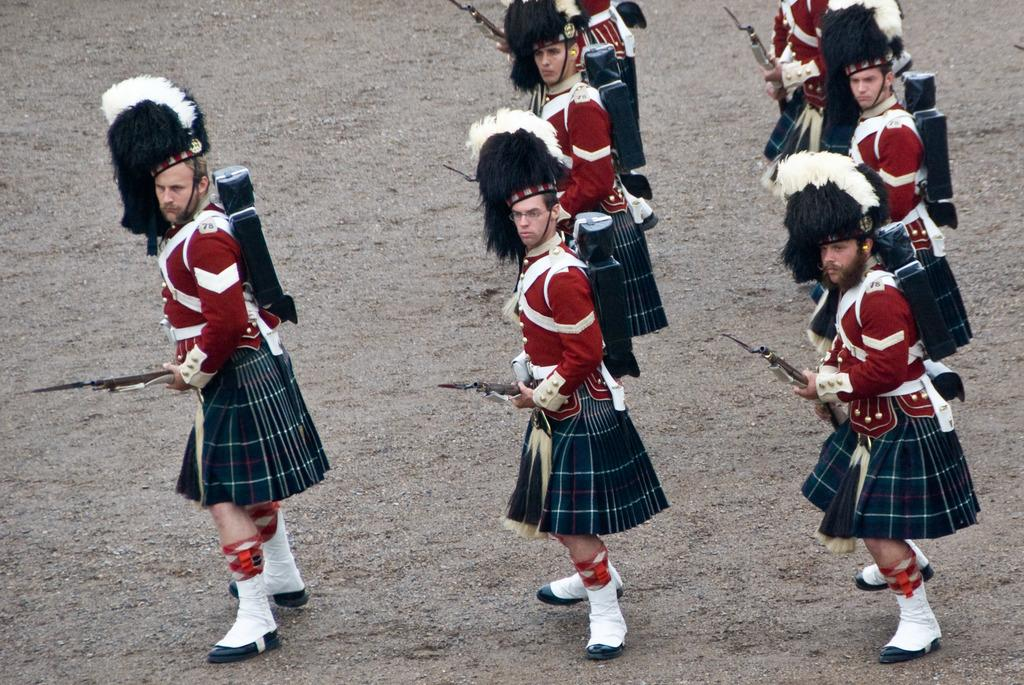Who or what can be seen in the image? There are people in the image. What are the people wearing? The people are wearing costumes. Where are the people standing? The people are standing on the ground. What are the people holding in their hands? The people are holding guns in their hands. What type of fuel is being used by the coach in the image? There is no coach or fuel present in the image; it features people wearing costumes and holding guns. 